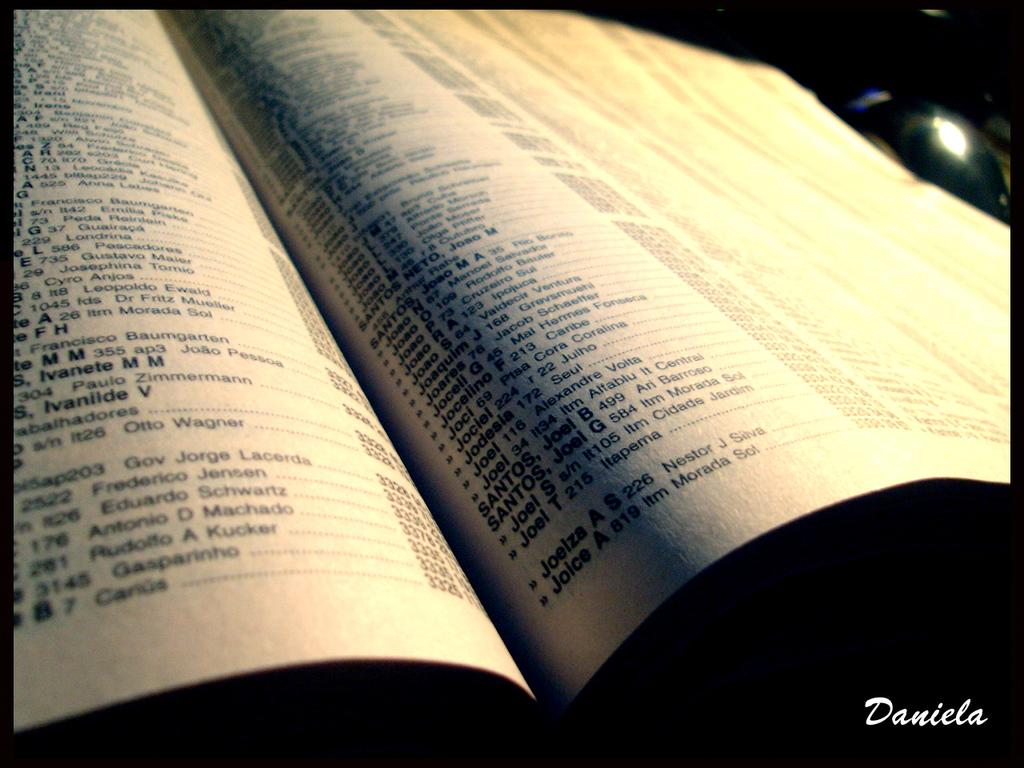Provide a one-sentence caption for the provided image. Names and addresses are listed in a booklet, the last entry on the right page is for Joice A. 